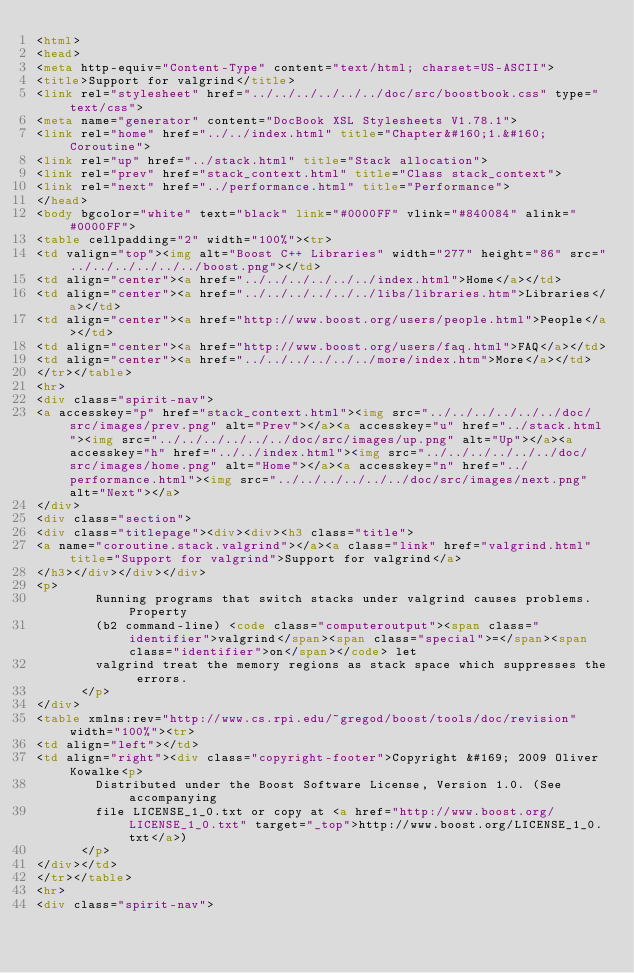Convert code to text. <code><loc_0><loc_0><loc_500><loc_500><_HTML_><html>
<head>
<meta http-equiv="Content-Type" content="text/html; charset=US-ASCII">
<title>Support for valgrind</title>
<link rel="stylesheet" href="../../../../../../doc/src/boostbook.css" type="text/css">
<meta name="generator" content="DocBook XSL Stylesheets V1.78.1">
<link rel="home" href="../../index.html" title="Chapter&#160;1.&#160;Coroutine">
<link rel="up" href="../stack.html" title="Stack allocation">
<link rel="prev" href="stack_context.html" title="Class stack_context">
<link rel="next" href="../performance.html" title="Performance">
</head>
<body bgcolor="white" text="black" link="#0000FF" vlink="#840084" alink="#0000FF">
<table cellpadding="2" width="100%"><tr>
<td valign="top"><img alt="Boost C++ Libraries" width="277" height="86" src="../../../../../../boost.png"></td>
<td align="center"><a href="../../../../../../index.html">Home</a></td>
<td align="center"><a href="../../../../../../libs/libraries.htm">Libraries</a></td>
<td align="center"><a href="http://www.boost.org/users/people.html">People</a></td>
<td align="center"><a href="http://www.boost.org/users/faq.html">FAQ</a></td>
<td align="center"><a href="../../../../../../more/index.htm">More</a></td>
</tr></table>
<hr>
<div class="spirit-nav">
<a accesskey="p" href="stack_context.html"><img src="../../../../../../doc/src/images/prev.png" alt="Prev"></a><a accesskey="u" href="../stack.html"><img src="../../../../../../doc/src/images/up.png" alt="Up"></a><a accesskey="h" href="../../index.html"><img src="../../../../../../doc/src/images/home.png" alt="Home"></a><a accesskey="n" href="../performance.html"><img src="../../../../../../doc/src/images/next.png" alt="Next"></a>
</div>
<div class="section">
<div class="titlepage"><div><div><h3 class="title">
<a name="coroutine.stack.valgrind"></a><a class="link" href="valgrind.html" title="Support for valgrind">Support for valgrind</a>
</h3></div></div></div>
<p>
        Running programs that switch stacks under valgrind causes problems. Property
        (b2 command-line) <code class="computeroutput"><span class="identifier">valgrind</span><span class="special">=</span><span class="identifier">on</span></code> let
        valgrind treat the memory regions as stack space which suppresses the errors.
      </p>
</div>
<table xmlns:rev="http://www.cs.rpi.edu/~gregod/boost/tools/doc/revision" width="100%"><tr>
<td align="left"></td>
<td align="right"><div class="copyright-footer">Copyright &#169; 2009 Oliver Kowalke<p>
        Distributed under the Boost Software License, Version 1.0. (See accompanying
        file LICENSE_1_0.txt or copy at <a href="http://www.boost.org/LICENSE_1_0.txt" target="_top">http://www.boost.org/LICENSE_1_0.txt</a>)
      </p>
</div></td>
</tr></table>
<hr>
<div class="spirit-nav"></code> 